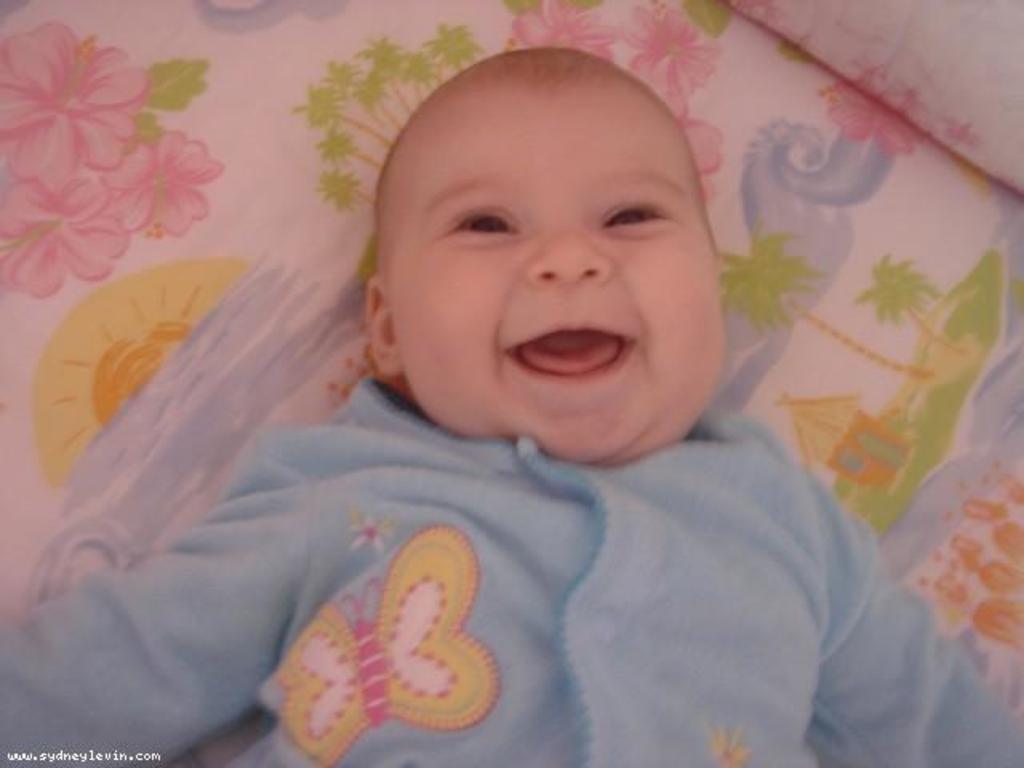In one or two sentences, can you explain what this image depicts? There is a baby in blue color dress, smiling and lying on a bed. Which is having a bed sheet and a pillow. In front of this baby, there is a watermark. 